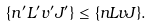Convert formula to latex. <formula><loc_0><loc_0><loc_500><loc_500>\{ n ^ { \prime } L ^ { \prime } v ^ { \prime } J ^ { \prime } \} \leq \{ n L v J \} .</formula> 